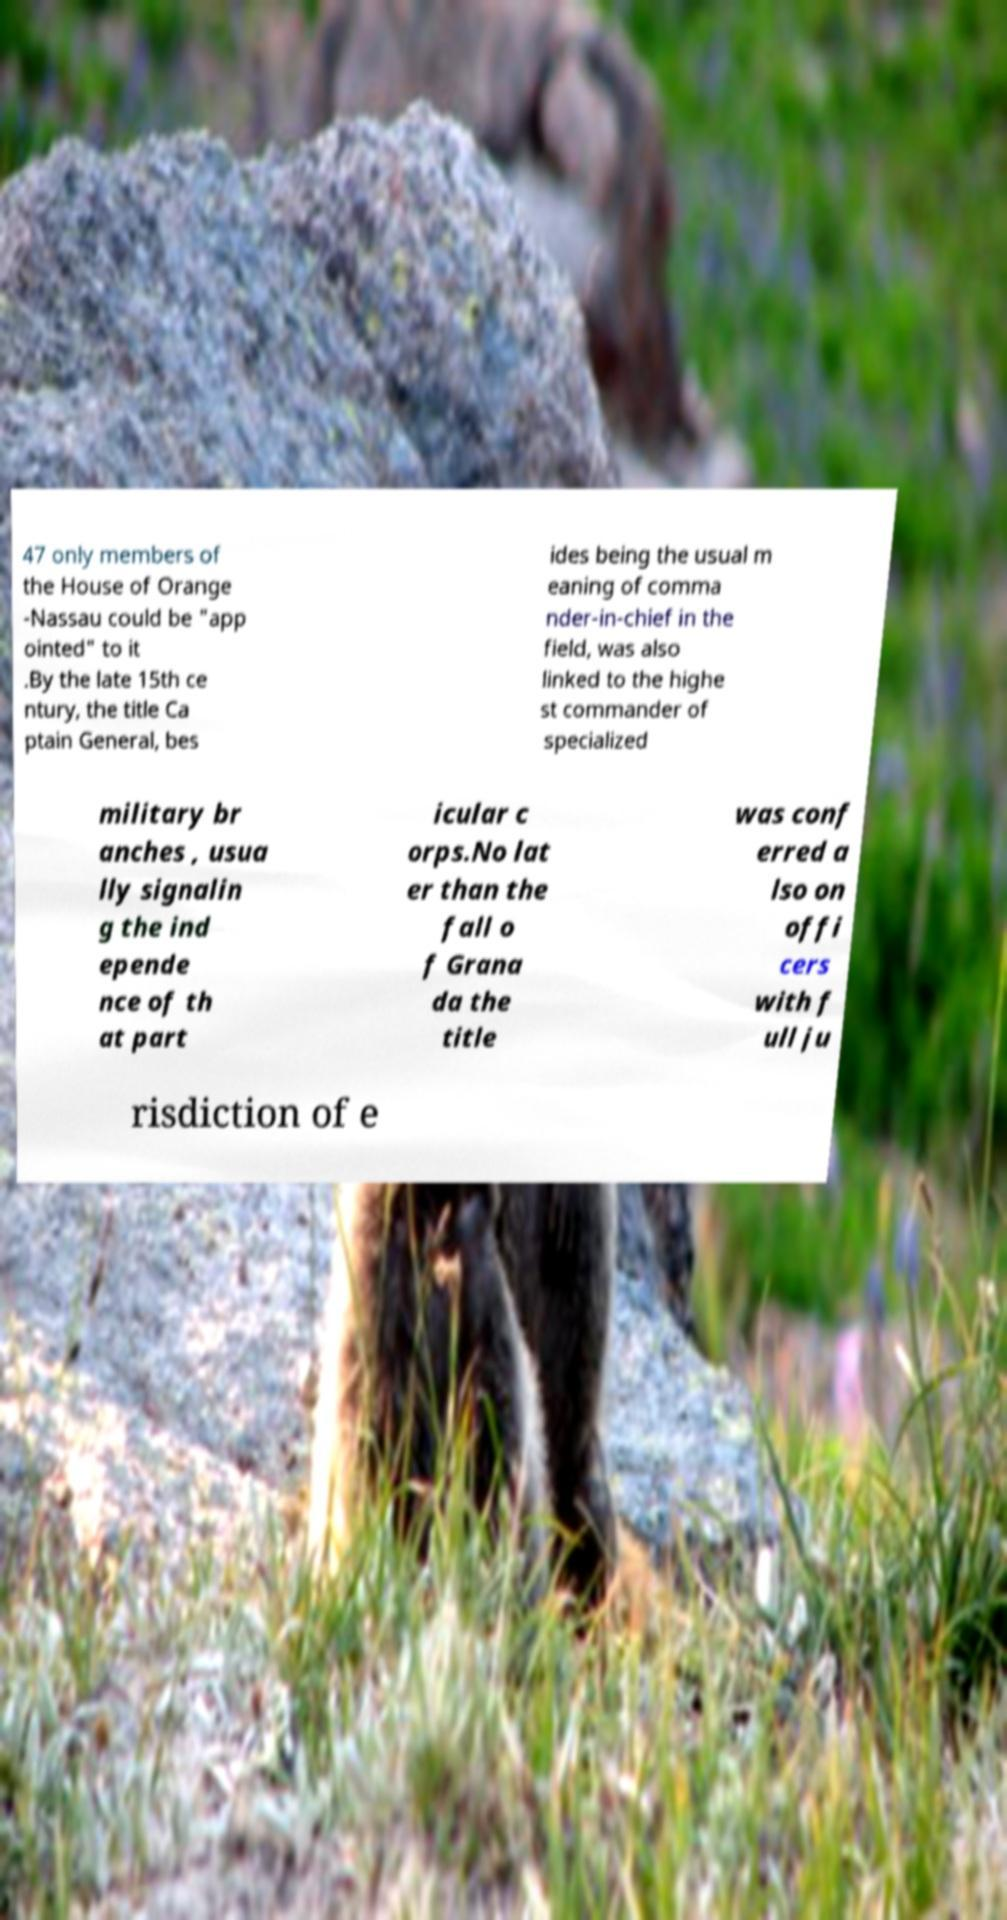There's text embedded in this image that I need extracted. Can you transcribe it verbatim? 47 only members of the House of Orange -Nassau could be "app ointed" to it .By the late 15th ce ntury, the title Ca ptain General, bes ides being the usual m eaning of comma nder-in-chief in the field, was also linked to the highe st commander of specialized military br anches , usua lly signalin g the ind epende nce of th at part icular c orps.No lat er than the fall o f Grana da the title was conf erred a lso on offi cers with f ull ju risdiction of e 